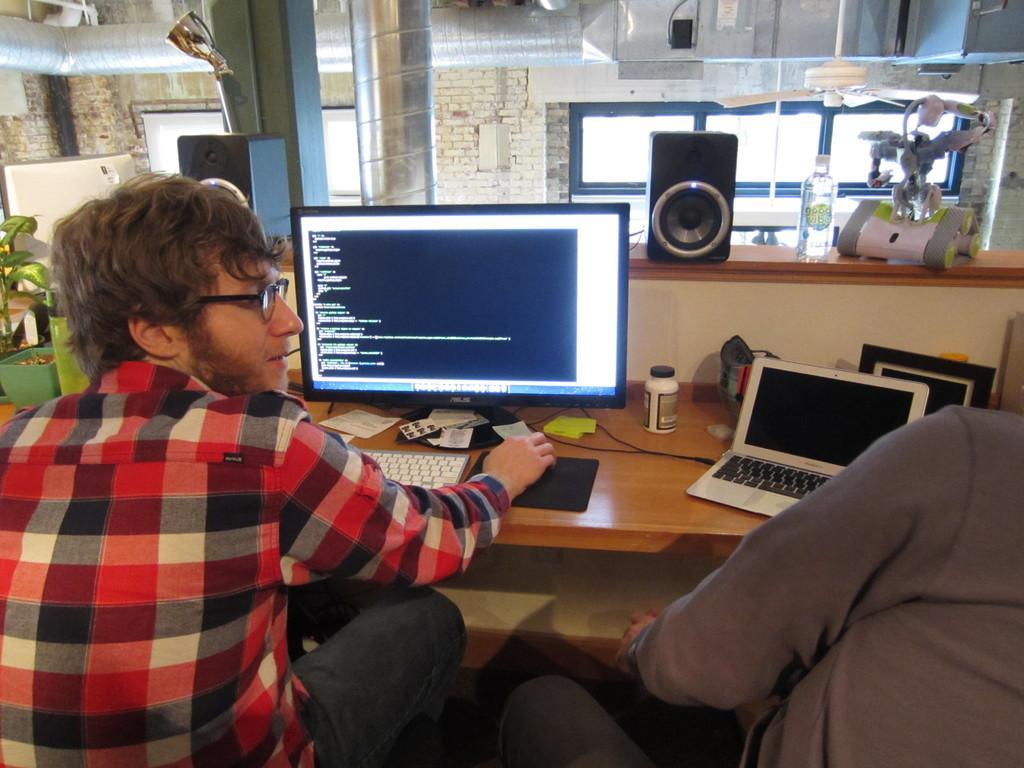Describe this image in one or two sentences. There are two people sitting. There is a laptop and a computer placed on a table. There is a speaker. There is a bottle placed on the table. There is plant. In the background there is a brick wall. There is a window. 